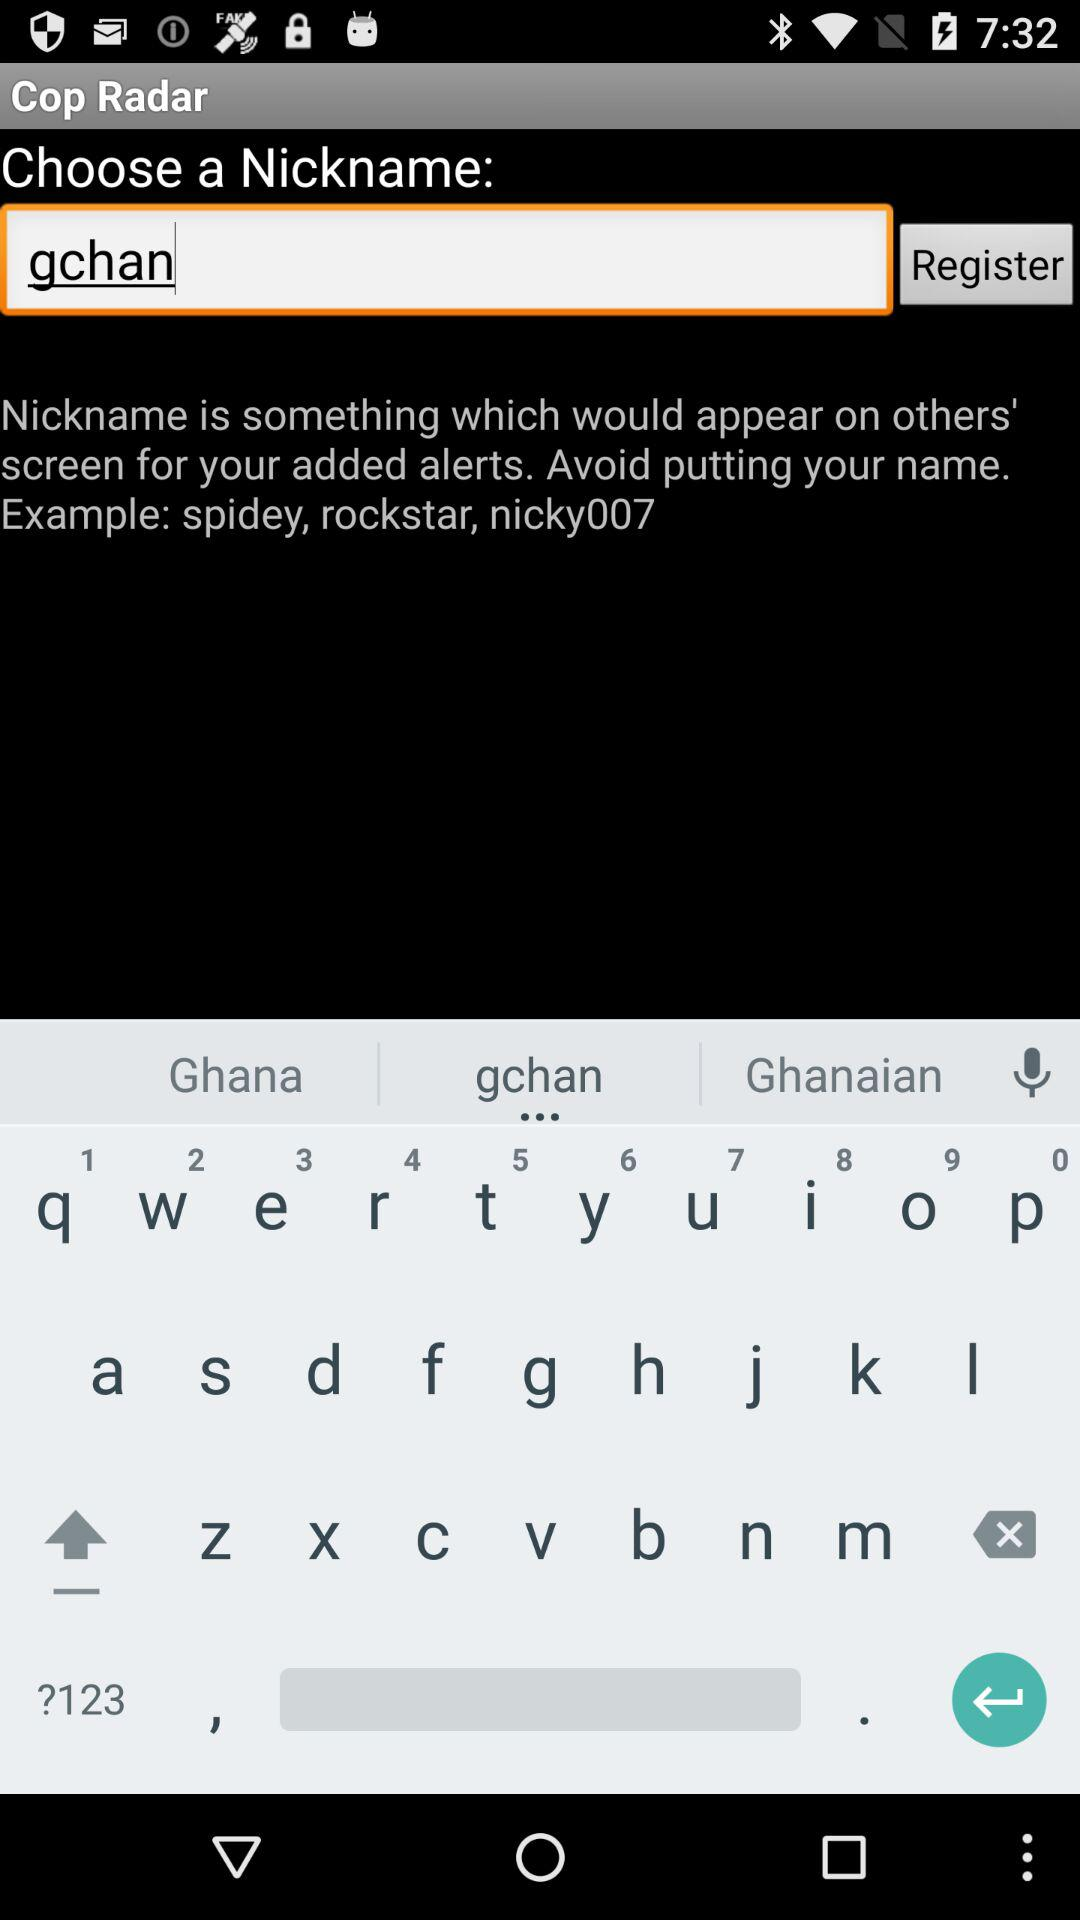What is the name of the application? The name of the application is "Cop Radar". 